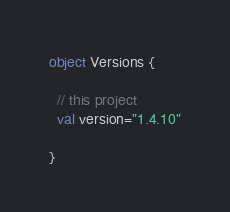Convert code to text. <code><loc_0><loc_0><loc_500><loc_500><_Scala_>object Versions {

  // this project
  val version="1.4.10"

}
</code> 